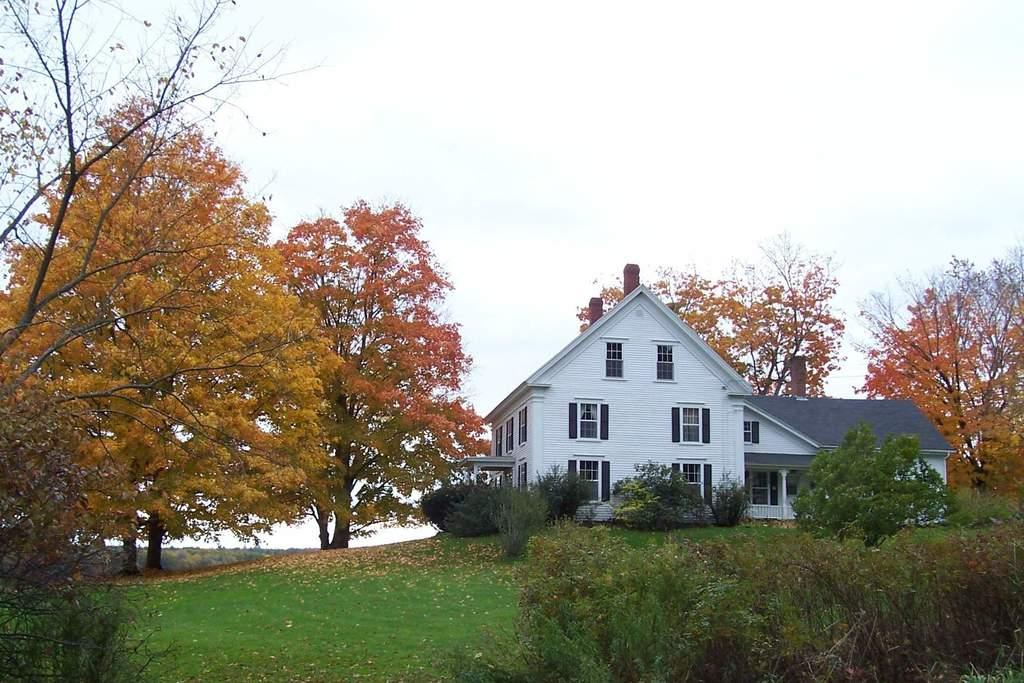What type of structure is present in the image? There is a building in the image. What type of vegetation can be seen in the image? There is grass, trees, and plants in the image. Is there a badge visible on the building in the image? There is no badge present on the building in the image. Can you see any evidence of a crime being committed in the image? There is no indication of a crime being committed in the image. 